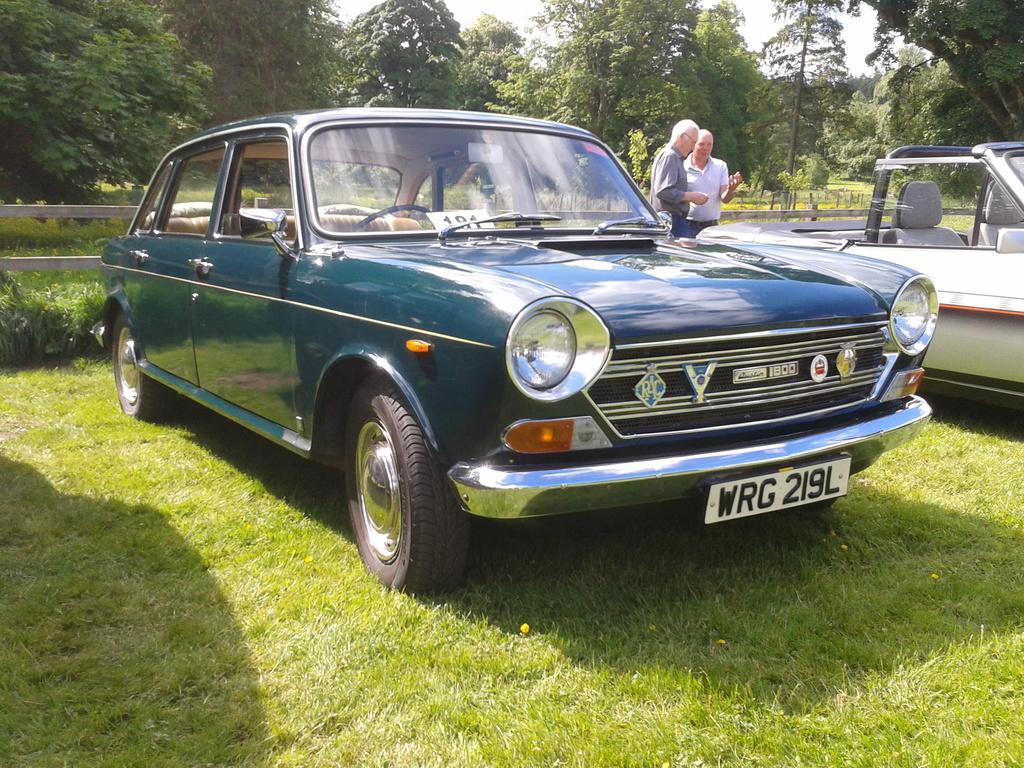How would you summarize this image in a sentence or two? Here we can see two cars on the grass. In the background there are two men standing at the cars,trees,fence and sky. 